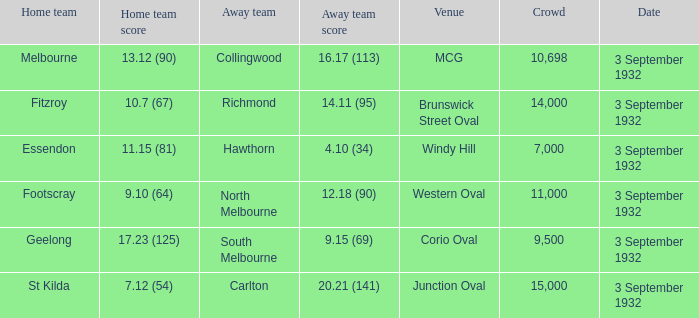What is the overall crowd size for the team with an away team score of 12.18 (90)? 11000.0. 